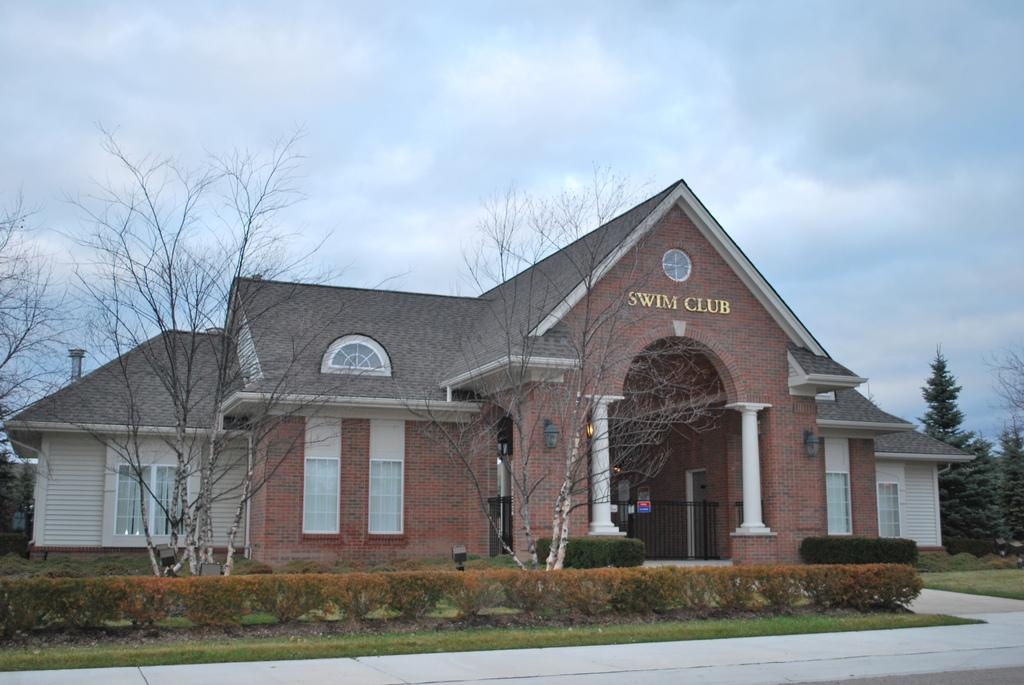What type of structure is in the image? There is a building in the image. What can be seen at the bottom of the image? The bottom of the image contains a road, grass, and plants. What is visible in the background of the image? There are many trees visible in the background of the image. What is visible at the top of the image? The sky is visible at the top of the image. What can be observed in the sky? Clouds are present in the sky. What type of birds are flying in formation in the image? There are no birds visible in the image. What theory is being applied to the building in the image? The image does not provide information about any specific theory being applied to the building. 